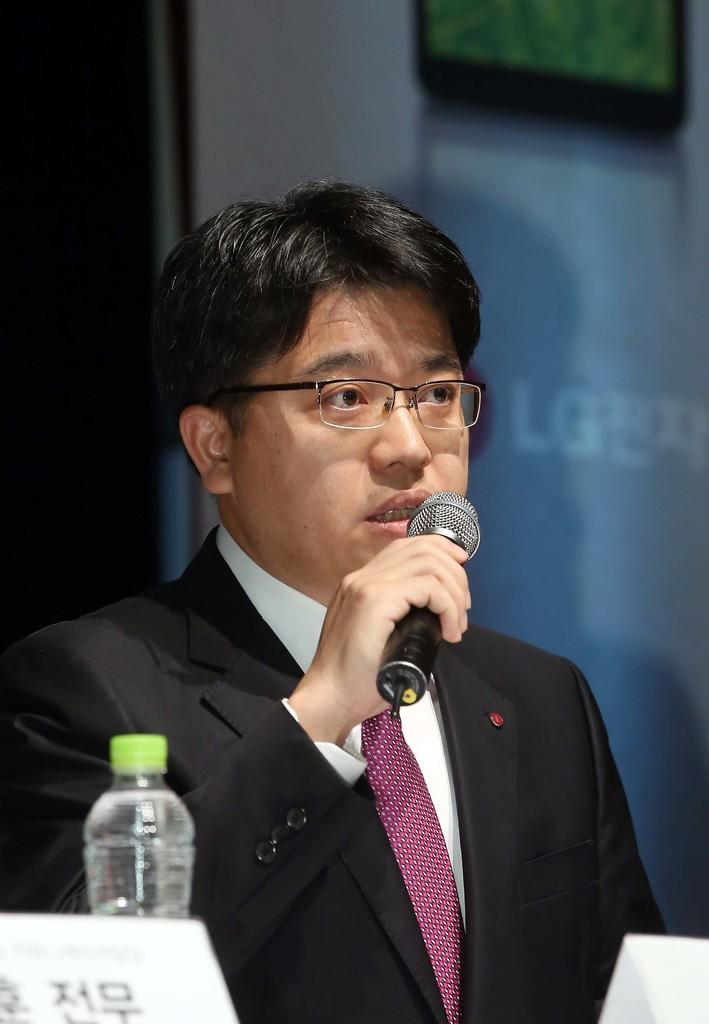Who is present in the image? There is a man in the image. What is the man wearing? The man is wearing a suit and tie. What is the man holding in the image? The man is holding a microphone. What accessory is the man wearing? The man is wearing glasses. Can you identify any other objects in the image? Yes, there is a water bottle in the image. What type of corn can be seen growing in the image? There is no corn present in the image; it features a man wearing a suit and tie, holding a microphone, and wearing glasses, along with a water bottle. 